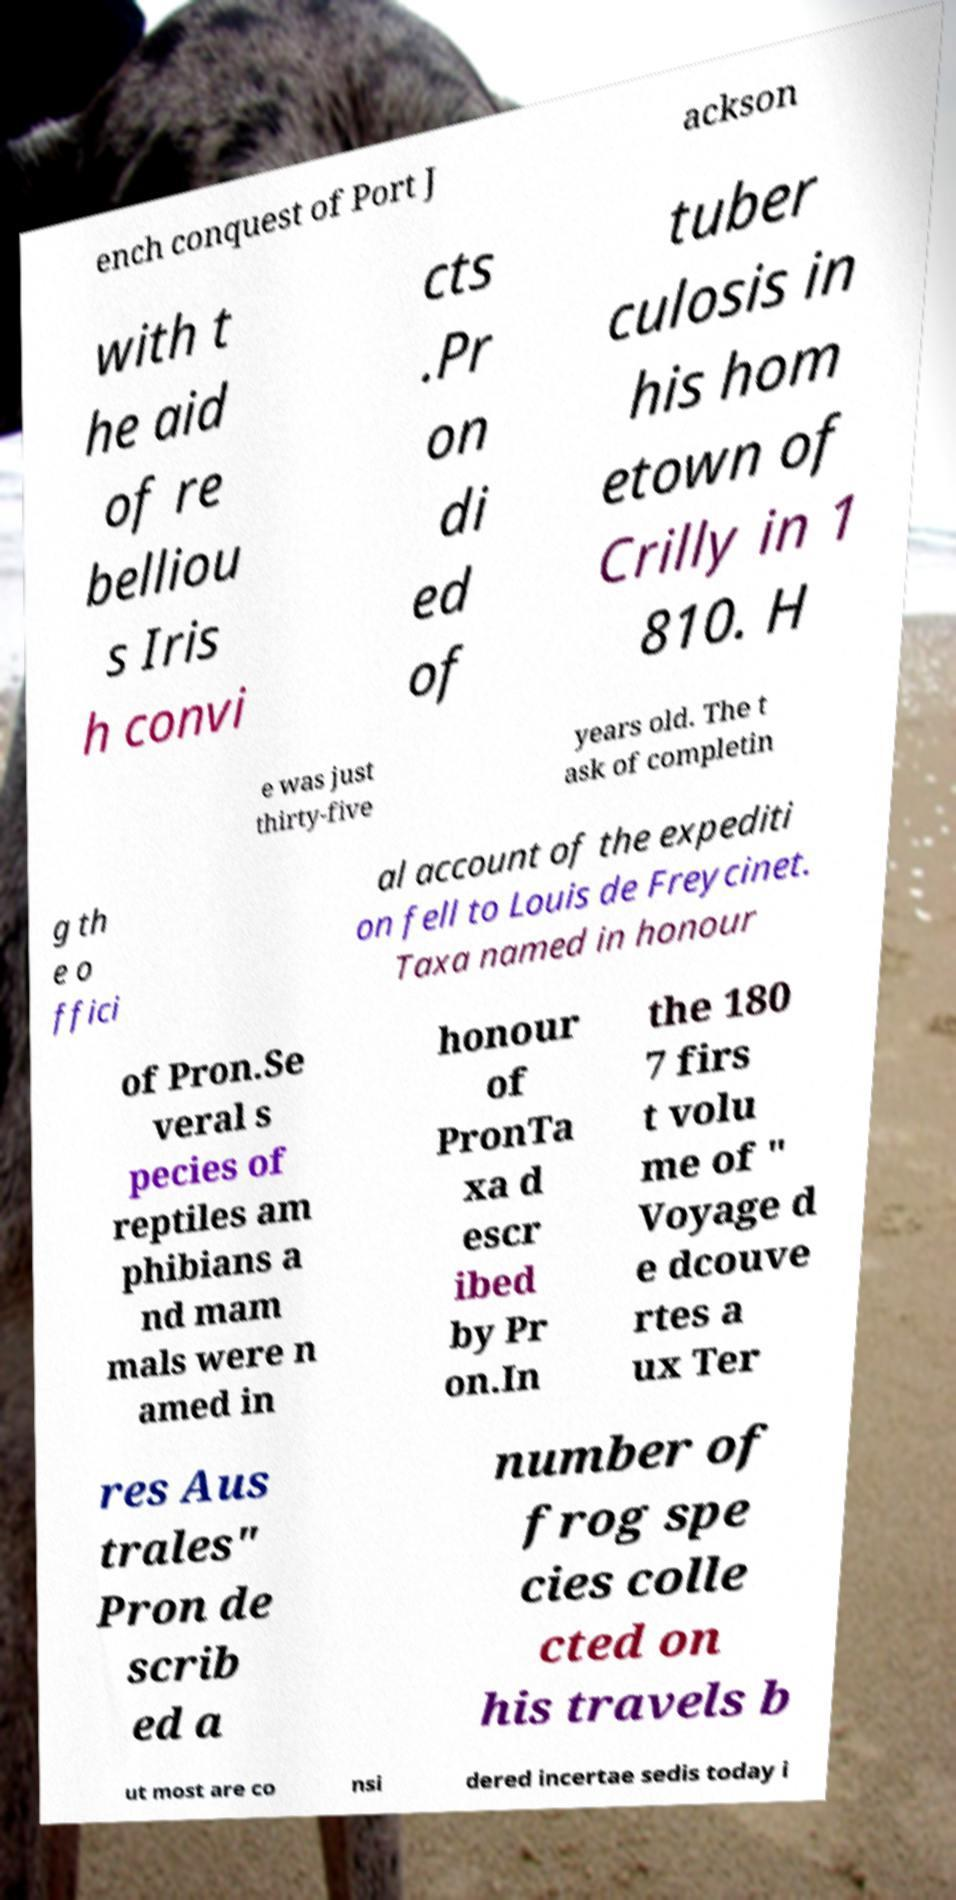Could you assist in decoding the text presented in this image and type it out clearly? ench conquest of Port J ackson with t he aid of re belliou s Iris h convi cts .Pr on di ed of tuber culosis in his hom etown of Crilly in 1 810. H e was just thirty-five years old. The t ask of completin g th e o ffici al account of the expediti on fell to Louis de Freycinet. Taxa named in honour of Pron.Se veral s pecies of reptiles am phibians a nd mam mals were n amed in honour of PronTa xa d escr ibed by Pr on.In the 180 7 firs t volu me of " Voyage d e dcouve rtes a ux Ter res Aus trales" Pron de scrib ed a number of frog spe cies colle cted on his travels b ut most are co nsi dered incertae sedis today i 